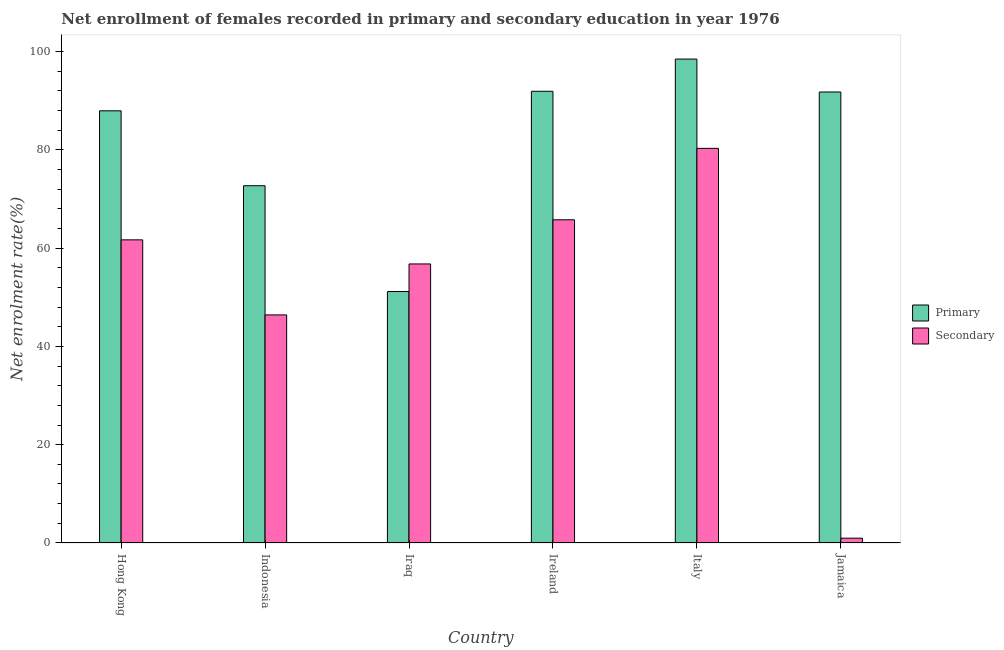How many different coloured bars are there?
Your answer should be compact. 2. How many groups of bars are there?
Make the answer very short. 6. Are the number of bars per tick equal to the number of legend labels?
Keep it short and to the point. Yes. How many bars are there on the 4th tick from the left?
Keep it short and to the point. 2. What is the label of the 6th group of bars from the left?
Offer a terse response. Jamaica. In how many cases, is the number of bars for a given country not equal to the number of legend labels?
Make the answer very short. 0. What is the enrollment rate in secondary education in Jamaica?
Offer a terse response. 0.98. Across all countries, what is the maximum enrollment rate in secondary education?
Offer a terse response. 80.28. Across all countries, what is the minimum enrollment rate in secondary education?
Your response must be concise. 0.98. In which country was the enrollment rate in secondary education minimum?
Keep it short and to the point. Jamaica. What is the total enrollment rate in primary education in the graph?
Give a very brief answer. 493.82. What is the difference between the enrollment rate in secondary education in Hong Kong and that in Ireland?
Offer a terse response. -4.08. What is the difference between the enrollment rate in secondary education in Italy and the enrollment rate in primary education in Ireland?
Your response must be concise. -11.61. What is the average enrollment rate in secondary education per country?
Your response must be concise. 51.97. What is the difference between the enrollment rate in secondary education and enrollment rate in primary education in Indonesia?
Ensure brevity in your answer.  -26.28. What is the ratio of the enrollment rate in primary education in Ireland to that in Jamaica?
Ensure brevity in your answer.  1. Is the difference between the enrollment rate in primary education in Indonesia and Italy greater than the difference between the enrollment rate in secondary education in Indonesia and Italy?
Keep it short and to the point. Yes. What is the difference between the highest and the second highest enrollment rate in secondary education?
Provide a short and direct response. 14.53. What is the difference between the highest and the lowest enrollment rate in primary education?
Your answer should be compact. 47.29. In how many countries, is the enrollment rate in primary education greater than the average enrollment rate in primary education taken over all countries?
Your answer should be compact. 4. Is the sum of the enrollment rate in primary education in Ireland and Italy greater than the maximum enrollment rate in secondary education across all countries?
Ensure brevity in your answer.  Yes. What does the 1st bar from the left in Hong Kong represents?
Provide a short and direct response. Primary. What does the 1st bar from the right in Italy represents?
Your answer should be very brief. Secondary. What is the difference between two consecutive major ticks on the Y-axis?
Make the answer very short. 20. Are the values on the major ticks of Y-axis written in scientific E-notation?
Ensure brevity in your answer.  No. Does the graph contain grids?
Your response must be concise. No. How are the legend labels stacked?
Your answer should be very brief. Vertical. What is the title of the graph?
Your answer should be very brief. Net enrollment of females recorded in primary and secondary education in year 1976. What is the label or title of the X-axis?
Make the answer very short. Country. What is the label or title of the Y-axis?
Give a very brief answer. Net enrolment rate(%). What is the Net enrolment rate(%) in Primary in Hong Kong?
Your answer should be compact. 87.92. What is the Net enrolment rate(%) in Secondary in Hong Kong?
Offer a terse response. 61.67. What is the Net enrolment rate(%) of Primary in Indonesia?
Offer a very short reply. 72.68. What is the Net enrolment rate(%) of Secondary in Indonesia?
Ensure brevity in your answer.  46.4. What is the Net enrolment rate(%) of Primary in Iraq?
Give a very brief answer. 51.16. What is the Net enrolment rate(%) in Secondary in Iraq?
Provide a succinct answer. 56.76. What is the Net enrolment rate(%) in Primary in Ireland?
Your answer should be compact. 91.89. What is the Net enrolment rate(%) in Secondary in Ireland?
Provide a succinct answer. 65.75. What is the Net enrolment rate(%) of Primary in Italy?
Ensure brevity in your answer.  98.44. What is the Net enrolment rate(%) of Secondary in Italy?
Your answer should be compact. 80.28. What is the Net enrolment rate(%) of Primary in Jamaica?
Ensure brevity in your answer.  91.74. What is the Net enrolment rate(%) in Secondary in Jamaica?
Keep it short and to the point. 0.98. Across all countries, what is the maximum Net enrolment rate(%) in Primary?
Make the answer very short. 98.44. Across all countries, what is the maximum Net enrolment rate(%) of Secondary?
Your answer should be compact. 80.28. Across all countries, what is the minimum Net enrolment rate(%) of Primary?
Ensure brevity in your answer.  51.16. Across all countries, what is the minimum Net enrolment rate(%) of Secondary?
Keep it short and to the point. 0.98. What is the total Net enrolment rate(%) of Primary in the graph?
Provide a short and direct response. 493.82. What is the total Net enrolment rate(%) of Secondary in the graph?
Offer a terse response. 311.83. What is the difference between the Net enrolment rate(%) of Primary in Hong Kong and that in Indonesia?
Your response must be concise. 15.24. What is the difference between the Net enrolment rate(%) of Secondary in Hong Kong and that in Indonesia?
Make the answer very short. 15.27. What is the difference between the Net enrolment rate(%) in Primary in Hong Kong and that in Iraq?
Your response must be concise. 36.76. What is the difference between the Net enrolment rate(%) in Secondary in Hong Kong and that in Iraq?
Provide a succinct answer. 4.9. What is the difference between the Net enrolment rate(%) of Primary in Hong Kong and that in Ireland?
Your answer should be compact. -3.98. What is the difference between the Net enrolment rate(%) in Secondary in Hong Kong and that in Ireland?
Your answer should be very brief. -4.08. What is the difference between the Net enrolment rate(%) of Primary in Hong Kong and that in Italy?
Your answer should be very brief. -10.53. What is the difference between the Net enrolment rate(%) in Secondary in Hong Kong and that in Italy?
Make the answer very short. -18.61. What is the difference between the Net enrolment rate(%) of Primary in Hong Kong and that in Jamaica?
Your response must be concise. -3.83. What is the difference between the Net enrolment rate(%) of Secondary in Hong Kong and that in Jamaica?
Your answer should be compact. 60.69. What is the difference between the Net enrolment rate(%) of Primary in Indonesia and that in Iraq?
Provide a short and direct response. 21.52. What is the difference between the Net enrolment rate(%) of Secondary in Indonesia and that in Iraq?
Your response must be concise. -10.37. What is the difference between the Net enrolment rate(%) in Primary in Indonesia and that in Ireland?
Keep it short and to the point. -19.21. What is the difference between the Net enrolment rate(%) of Secondary in Indonesia and that in Ireland?
Provide a short and direct response. -19.35. What is the difference between the Net enrolment rate(%) of Primary in Indonesia and that in Italy?
Give a very brief answer. -25.76. What is the difference between the Net enrolment rate(%) in Secondary in Indonesia and that in Italy?
Give a very brief answer. -33.88. What is the difference between the Net enrolment rate(%) in Primary in Indonesia and that in Jamaica?
Offer a very short reply. -19.06. What is the difference between the Net enrolment rate(%) of Secondary in Indonesia and that in Jamaica?
Provide a short and direct response. 45.41. What is the difference between the Net enrolment rate(%) in Primary in Iraq and that in Ireland?
Give a very brief answer. -40.73. What is the difference between the Net enrolment rate(%) of Secondary in Iraq and that in Ireland?
Your response must be concise. -8.98. What is the difference between the Net enrolment rate(%) of Primary in Iraq and that in Italy?
Provide a succinct answer. -47.29. What is the difference between the Net enrolment rate(%) in Secondary in Iraq and that in Italy?
Offer a very short reply. -23.51. What is the difference between the Net enrolment rate(%) in Primary in Iraq and that in Jamaica?
Make the answer very short. -40.59. What is the difference between the Net enrolment rate(%) of Secondary in Iraq and that in Jamaica?
Offer a terse response. 55.78. What is the difference between the Net enrolment rate(%) in Primary in Ireland and that in Italy?
Give a very brief answer. -6.55. What is the difference between the Net enrolment rate(%) of Secondary in Ireland and that in Italy?
Offer a terse response. -14.53. What is the difference between the Net enrolment rate(%) in Primary in Ireland and that in Jamaica?
Provide a succinct answer. 0.15. What is the difference between the Net enrolment rate(%) in Secondary in Ireland and that in Jamaica?
Your answer should be very brief. 64.76. What is the difference between the Net enrolment rate(%) of Primary in Italy and that in Jamaica?
Your answer should be compact. 6.7. What is the difference between the Net enrolment rate(%) in Secondary in Italy and that in Jamaica?
Keep it short and to the point. 79.3. What is the difference between the Net enrolment rate(%) of Primary in Hong Kong and the Net enrolment rate(%) of Secondary in Indonesia?
Keep it short and to the point. 41.52. What is the difference between the Net enrolment rate(%) of Primary in Hong Kong and the Net enrolment rate(%) of Secondary in Iraq?
Your answer should be compact. 31.15. What is the difference between the Net enrolment rate(%) in Primary in Hong Kong and the Net enrolment rate(%) in Secondary in Ireland?
Offer a terse response. 22.17. What is the difference between the Net enrolment rate(%) in Primary in Hong Kong and the Net enrolment rate(%) in Secondary in Italy?
Your answer should be compact. 7.64. What is the difference between the Net enrolment rate(%) of Primary in Hong Kong and the Net enrolment rate(%) of Secondary in Jamaica?
Your response must be concise. 86.93. What is the difference between the Net enrolment rate(%) in Primary in Indonesia and the Net enrolment rate(%) in Secondary in Iraq?
Give a very brief answer. 15.91. What is the difference between the Net enrolment rate(%) in Primary in Indonesia and the Net enrolment rate(%) in Secondary in Ireland?
Give a very brief answer. 6.93. What is the difference between the Net enrolment rate(%) of Primary in Indonesia and the Net enrolment rate(%) of Secondary in Italy?
Keep it short and to the point. -7.6. What is the difference between the Net enrolment rate(%) in Primary in Indonesia and the Net enrolment rate(%) in Secondary in Jamaica?
Your answer should be compact. 71.7. What is the difference between the Net enrolment rate(%) of Primary in Iraq and the Net enrolment rate(%) of Secondary in Ireland?
Offer a terse response. -14.59. What is the difference between the Net enrolment rate(%) of Primary in Iraq and the Net enrolment rate(%) of Secondary in Italy?
Your answer should be very brief. -29.12. What is the difference between the Net enrolment rate(%) of Primary in Iraq and the Net enrolment rate(%) of Secondary in Jamaica?
Make the answer very short. 50.17. What is the difference between the Net enrolment rate(%) of Primary in Ireland and the Net enrolment rate(%) of Secondary in Italy?
Your answer should be very brief. 11.61. What is the difference between the Net enrolment rate(%) in Primary in Ireland and the Net enrolment rate(%) in Secondary in Jamaica?
Give a very brief answer. 90.91. What is the difference between the Net enrolment rate(%) of Primary in Italy and the Net enrolment rate(%) of Secondary in Jamaica?
Provide a succinct answer. 97.46. What is the average Net enrolment rate(%) in Primary per country?
Your answer should be compact. 82.3. What is the average Net enrolment rate(%) in Secondary per country?
Offer a very short reply. 51.97. What is the difference between the Net enrolment rate(%) of Primary and Net enrolment rate(%) of Secondary in Hong Kong?
Give a very brief answer. 26.25. What is the difference between the Net enrolment rate(%) in Primary and Net enrolment rate(%) in Secondary in Indonesia?
Your answer should be very brief. 26.28. What is the difference between the Net enrolment rate(%) in Primary and Net enrolment rate(%) in Secondary in Iraq?
Offer a terse response. -5.61. What is the difference between the Net enrolment rate(%) of Primary and Net enrolment rate(%) of Secondary in Ireland?
Give a very brief answer. 26.14. What is the difference between the Net enrolment rate(%) in Primary and Net enrolment rate(%) in Secondary in Italy?
Offer a very short reply. 18.16. What is the difference between the Net enrolment rate(%) in Primary and Net enrolment rate(%) in Secondary in Jamaica?
Your answer should be very brief. 90.76. What is the ratio of the Net enrolment rate(%) of Primary in Hong Kong to that in Indonesia?
Keep it short and to the point. 1.21. What is the ratio of the Net enrolment rate(%) of Secondary in Hong Kong to that in Indonesia?
Provide a succinct answer. 1.33. What is the ratio of the Net enrolment rate(%) of Primary in Hong Kong to that in Iraq?
Ensure brevity in your answer.  1.72. What is the ratio of the Net enrolment rate(%) in Secondary in Hong Kong to that in Iraq?
Your answer should be very brief. 1.09. What is the ratio of the Net enrolment rate(%) of Primary in Hong Kong to that in Ireland?
Give a very brief answer. 0.96. What is the ratio of the Net enrolment rate(%) of Secondary in Hong Kong to that in Ireland?
Offer a terse response. 0.94. What is the ratio of the Net enrolment rate(%) of Primary in Hong Kong to that in Italy?
Give a very brief answer. 0.89. What is the ratio of the Net enrolment rate(%) in Secondary in Hong Kong to that in Italy?
Your answer should be very brief. 0.77. What is the ratio of the Net enrolment rate(%) of Secondary in Hong Kong to that in Jamaica?
Make the answer very short. 62.83. What is the ratio of the Net enrolment rate(%) in Primary in Indonesia to that in Iraq?
Offer a very short reply. 1.42. What is the ratio of the Net enrolment rate(%) of Secondary in Indonesia to that in Iraq?
Ensure brevity in your answer.  0.82. What is the ratio of the Net enrolment rate(%) in Primary in Indonesia to that in Ireland?
Ensure brevity in your answer.  0.79. What is the ratio of the Net enrolment rate(%) of Secondary in Indonesia to that in Ireland?
Your answer should be compact. 0.71. What is the ratio of the Net enrolment rate(%) of Primary in Indonesia to that in Italy?
Give a very brief answer. 0.74. What is the ratio of the Net enrolment rate(%) of Secondary in Indonesia to that in Italy?
Offer a very short reply. 0.58. What is the ratio of the Net enrolment rate(%) in Primary in Indonesia to that in Jamaica?
Keep it short and to the point. 0.79. What is the ratio of the Net enrolment rate(%) of Secondary in Indonesia to that in Jamaica?
Your response must be concise. 47.27. What is the ratio of the Net enrolment rate(%) in Primary in Iraq to that in Ireland?
Your answer should be compact. 0.56. What is the ratio of the Net enrolment rate(%) of Secondary in Iraq to that in Ireland?
Offer a very short reply. 0.86. What is the ratio of the Net enrolment rate(%) in Primary in Iraq to that in Italy?
Your answer should be compact. 0.52. What is the ratio of the Net enrolment rate(%) in Secondary in Iraq to that in Italy?
Give a very brief answer. 0.71. What is the ratio of the Net enrolment rate(%) in Primary in Iraq to that in Jamaica?
Offer a terse response. 0.56. What is the ratio of the Net enrolment rate(%) of Secondary in Iraq to that in Jamaica?
Keep it short and to the point. 57.83. What is the ratio of the Net enrolment rate(%) in Primary in Ireland to that in Italy?
Keep it short and to the point. 0.93. What is the ratio of the Net enrolment rate(%) in Secondary in Ireland to that in Italy?
Provide a short and direct response. 0.82. What is the ratio of the Net enrolment rate(%) of Primary in Ireland to that in Jamaica?
Your answer should be very brief. 1. What is the ratio of the Net enrolment rate(%) of Secondary in Ireland to that in Jamaica?
Give a very brief answer. 66.99. What is the ratio of the Net enrolment rate(%) in Primary in Italy to that in Jamaica?
Your response must be concise. 1.07. What is the ratio of the Net enrolment rate(%) in Secondary in Italy to that in Jamaica?
Give a very brief answer. 81.79. What is the difference between the highest and the second highest Net enrolment rate(%) in Primary?
Offer a terse response. 6.55. What is the difference between the highest and the second highest Net enrolment rate(%) of Secondary?
Offer a very short reply. 14.53. What is the difference between the highest and the lowest Net enrolment rate(%) of Primary?
Offer a very short reply. 47.29. What is the difference between the highest and the lowest Net enrolment rate(%) of Secondary?
Keep it short and to the point. 79.3. 